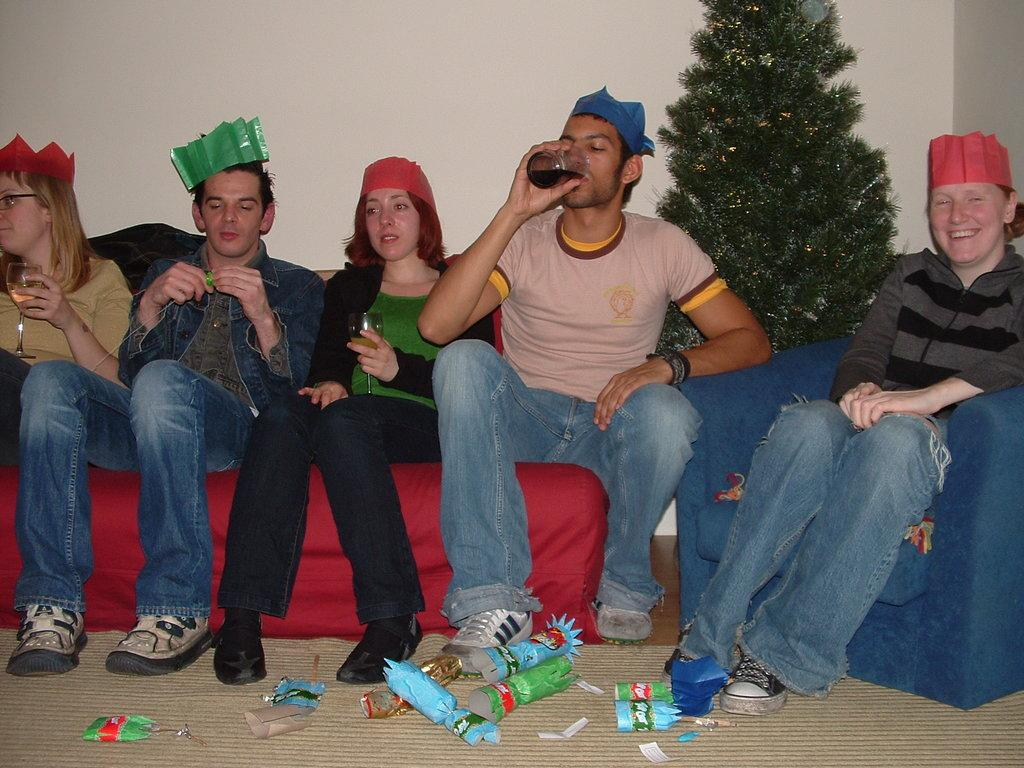What are the people in the image doing? The people in the image are sitting. What are the people holding in their hands? The people are holding glasses. What can be seen in the background of the image? There is an xmas tree and a wall in the background of the image. What is present at the bottom of the image? Papers are present on a mat at the bottom of the image. What is the condition of the table in the image? There is no table present in the image. How many groups of people can be seen in the image? There is only one group of people in the image, as they are all sitting together. 